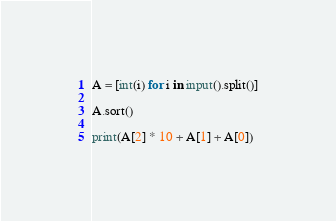Convert code to text. <code><loc_0><loc_0><loc_500><loc_500><_Python_>A = [int(i) for i in input().split()]

A.sort()

print(A[2] * 10 + A[1] + A[0])</code> 